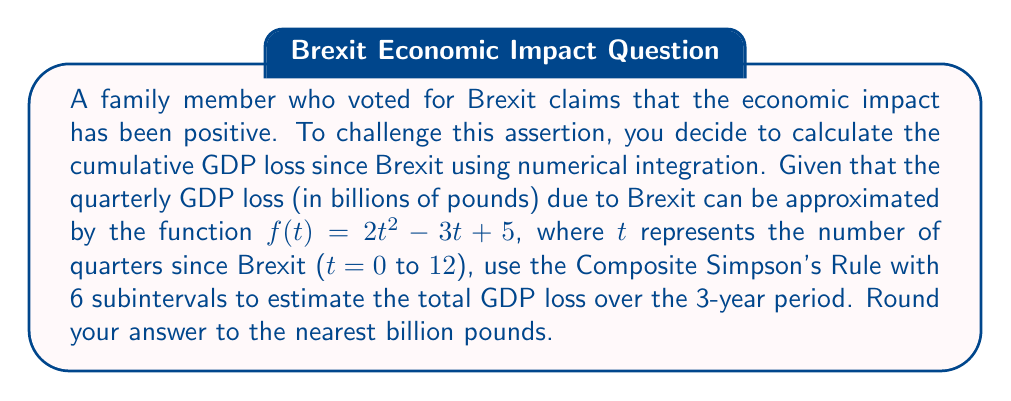Solve this math problem. To solve this problem, we'll use the Composite Simpson's Rule for numerical integration:

1) The Composite Simpson's Rule formula is:

   $$\int_{a}^{b} f(x) dx \approx \frac{h}{3}[f(x_0) + 4f(x_1) + 2f(x_2) + 4f(x_3) + 2f(x_4) + 4f(x_5) + f(x_6)]$$

   where $h = \frac{b-a}{n}$, $n$ is the number of subintervals (must be even), and $x_i = a + ih$.

2) In our case:
   $a = 0$, $b = 12$, $n = 6$
   $h = \frac{12-0}{6} = 2$

3) Calculate the $x_i$ values:
   $x_0 = 0$, $x_1 = 2$, $x_2 = 4$, $x_3 = 6$, $x_4 = 8$, $x_5 = 10$, $x_6 = 12$

4) Evaluate $f(x_i)$ for each $x_i$:
   $f(x_0) = f(0) = 2(0)^2 - 3(0) + 5 = 5$
   $f(x_1) = f(2) = 2(2)^2 - 3(2) + 5 = 7$
   $f(x_2) = f(4) = 2(4)^2 - 3(4) + 5 = 21$
   $f(x_3) = f(6) = 2(6)^2 - 3(6) + 5 = 47$
   $f(x_4) = f(8) = 2(8)^2 - 3(8) + 5 = 85$
   $f(x_5) = f(10) = 2(10)^2 - 3(10) + 5 = 135$
   $f(x_6) = f(12) = 2(12)^2 - 3(12) + 5 = 197$

5) Apply the Composite Simpson's Rule:

   $$\frac{2}{3}[5 + 4(7) + 2(21) + 4(47) + 2(85) + 4(135) + 197]$$
   $$= \frac{2}{3}[5 + 28 + 42 + 188 + 170 + 540 + 197]$$
   $$= \frac{2}{3}[1170] = 780$$

6) The result, 780, represents the total GDP loss in billions of pounds over the 3-year period.
Answer: 780 billion pounds 